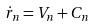<formula> <loc_0><loc_0><loc_500><loc_500>\dot { r } _ { n } = V _ { n } + C _ { n }</formula> 